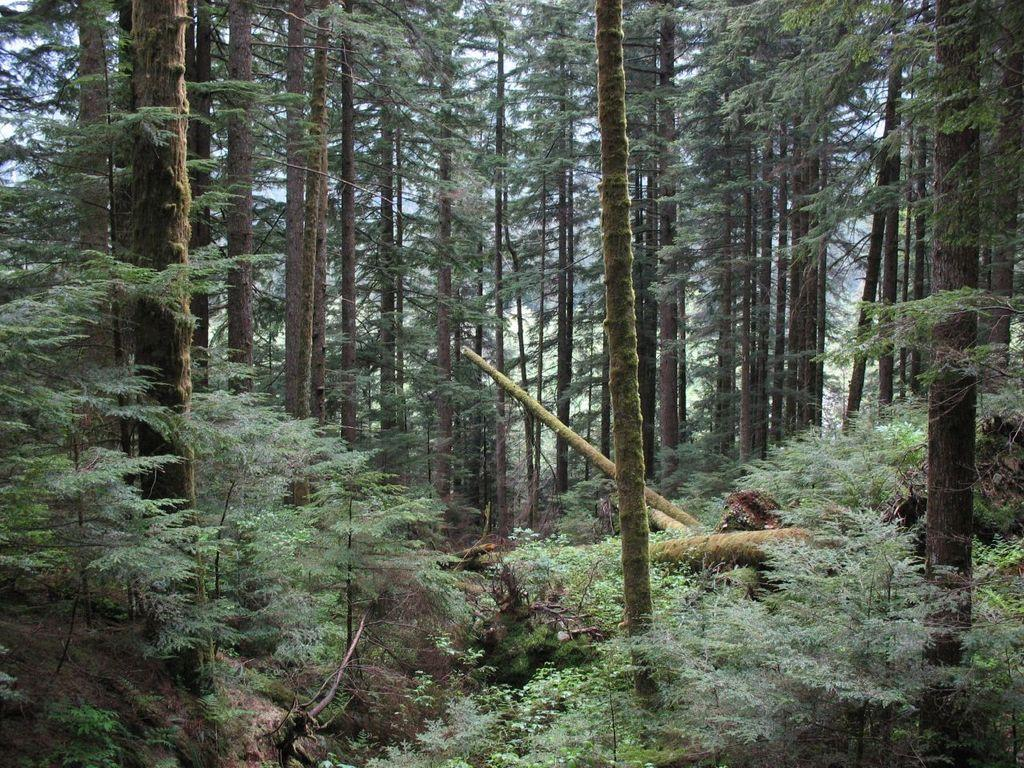What type of environment is shown in the image? The image depicts a forest. What can be observed about the trees in the forest? There are numerous trees in the forest. Are there any fallen trees visible in the image? Yes, there are fallen trees visible in the image. What type of soap can be seen hanging from the branches of the trees in the image? There is no soap present in the image; it depicts a forest with trees and fallen trees. Can you spot any toads or rabbits in the image? There is no mention of toads or rabbits in the provided facts, and they are not visible in the image. 